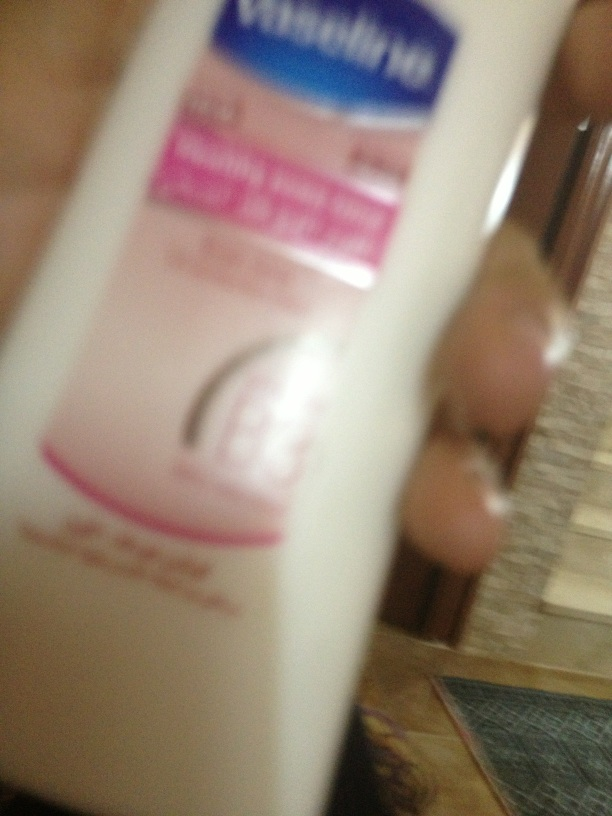Can you identify what type of product this is? This is a bottle of Vaseline lotion, a type of moisturizing lotion used to hydrate and soften the skin. What are some benefits of using this type of lotion? Using Vaseline lotion can help to moisturize dry skin, improve skin softness, and create a barrier that protects your skin from harsh environmental factors. It is particularly good for treating rough spots and can help to maintain smooth, healthy skin. 